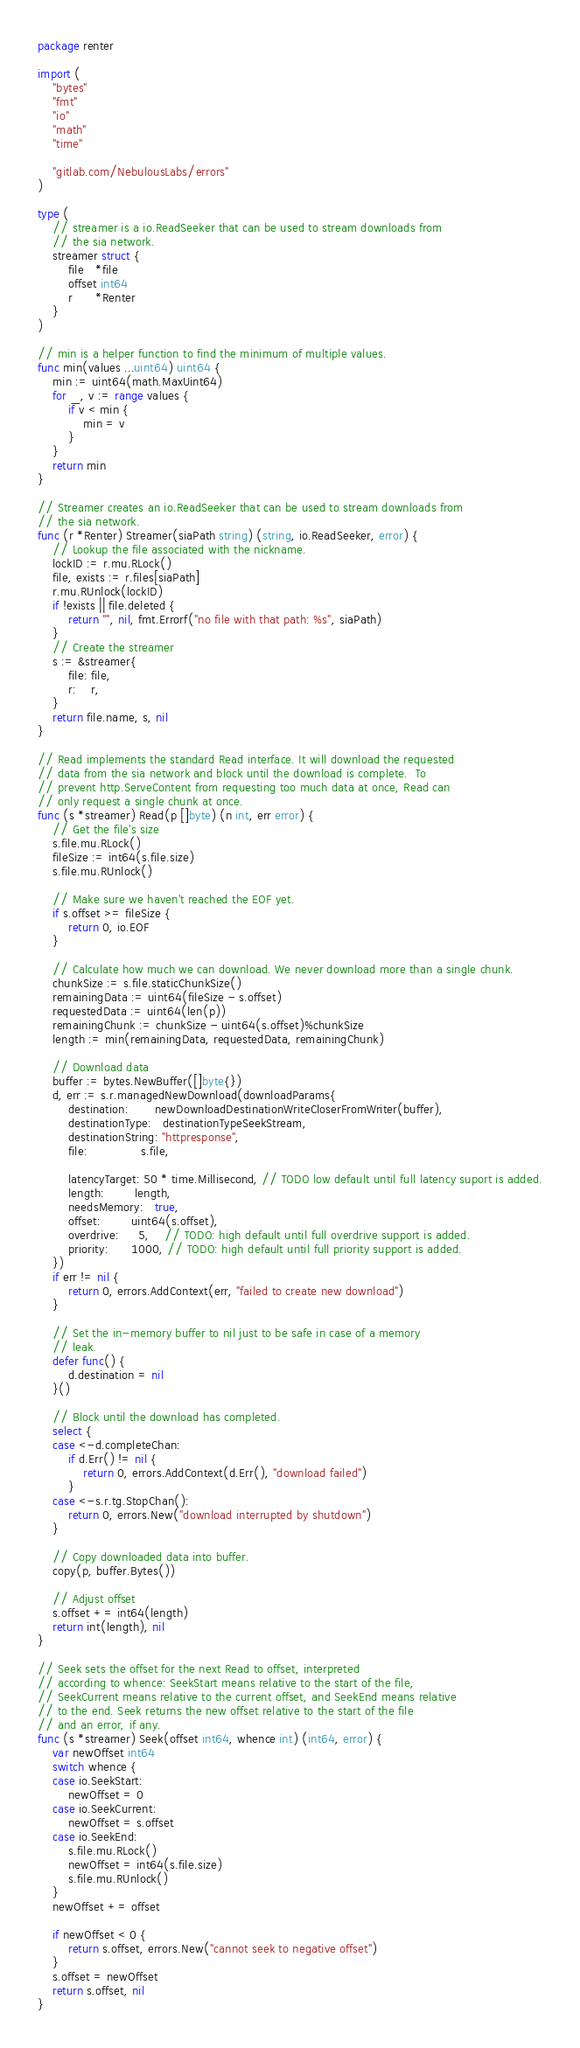<code> <loc_0><loc_0><loc_500><loc_500><_Go_>package renter

import (
	"bytes"
	"fmt"
	"io"
	"math"
	"time"

	"gitlab.com/NebulousLabs/errors"
)

type (
	// streamer is a io.ReadSeeker that can be used to stream downloads from
	// the sia network.
	streamer struct {
		file   *file
		offset int64
		r      *Renter
	}
)

// min is a helper function to find the minimum of multiple values.
func min(values ...uint64) uint64 {
	min := uint64(math.MaxUint64)
	for _, v := range values {
		if v < min {
			min = v
		}
	}
	return min
}

// Streamer creates an io.ReadSeeker that can be used to stream downloads from
// the sia network.
func (r *Renter) Streamer(siaPath string) (string, io.ReadSeeker, error) {
	// Lookup the file associated with the nickname.
	lockID := r.mu.RLock()
	file, exists := r.files[siaPath]
	r.mu.RUnlock(lockID)
	if !exists || file.deleted {
		return "", nil, fmt.Errorf("no file with that path: %s", siaPath)
	}
	// Create the streamer
	s := &streamer{
		file: file,
		r:    r,
	}
	return file.name, s, nil
}

// Read implements the standard Read interface. It will download the requested
// data from the sia network and block until the download is complete.  To
// prevent http.ServeContent from requesting too much data at once, Read can
// only request a single chunk at once.
func (s *streamer) Read(p []byte) (n int, err error) {
	// Get the file's size
	s.file.mu.RLock()
	fileSize := int64(s.file.size)
	s.file.mu.RUnlock()

	// Make sure we haven't reached the EOF yet.
	if s.offset >= fileSize {
		return 0, io.EOF
	}

	// Calculate how much we can download. We never download more than a single chunk.
	chunkSize := s.file.staticChunkSize()
	remainingData := uint64(fileSize - s.offset)
	requestedData := uint64(len(p))
	remainingChunk := chunkSize - uint64(s.offset)%chunkSize
	length := min(remainingData, requestedData, remainingChunk)

	// Download data
	buffer := bytes.NewBuffer([]byte{})
	d, err := s.r.managedNewDownload(downloadParams{
		destination:       newDownloadDestinationWriteCloserFromWriter(buffer),
		destinationType:   destinationTypeSeekStream,
		destinationString: "httpresponse",
		file:              s.file,

		latencyTarget: 50 * time.Millisecond, // TODO low default until full latency suport is added.
		length:        length,
		needsMemory:   true,
		offset:        uint64(s.offset),
		overdrive:     5,    // TODO: high default until full overdrive support is added.
		priority:      1000, // TODO: high default until full priority support is added.
	})
	if err != nil {
		return 0, errors.AddContext(err, "failed to create new download")
	}

	// Set the in-memory buffer to nil just to be safe in case of a memory
	// leak.
	defer func() {
		d.destination = nil
	}()

	// Block until the download has completed.
	select {
	case <-d.completeChan:
		if d.Err() != nil {
			return 0, errors.AddContext(d.Err(), "download failed")
		}
	case <-s.r.tg.StopChan():
		return 0, errors.New("download interrupted by shutdown")
	}

	// Copy downloaded data into buffer.
	copy(p, buffer.Bytes())

	// Adjust offset
	s.offset += int64(length)
	return int(length), nil
}

// Seek sets the offset for the next Read to offset, interpreted
// according to whence: SeekStart means relative to the start of the file,
// SeekCurrent means relative to the current offset, and SeekEnd means relative
// to the end. Seek returns the new offset relative to the start of the file
// and an error, if any.
func (s *streamer) Seek(offset int64, whence int) (int64, error) {
	var newOffset int64
	switch whence {
	case io.SeekStart:
		newOffset = 0
	case io.SeekCurrent:
		newOffset = s.offset
	case io.SeekEnd:
		s.file.mu.RLock()
		newOffset = int64(s.file.size)
		s.file.mu.RUnlock()
	}
	newOffset += offset

	if newOffset < 0 {
		return s.offset, errors.New("cannot seek to negative offset")
	}
	s.offset = newOffset
	return s.offset, nil
}
</code> 